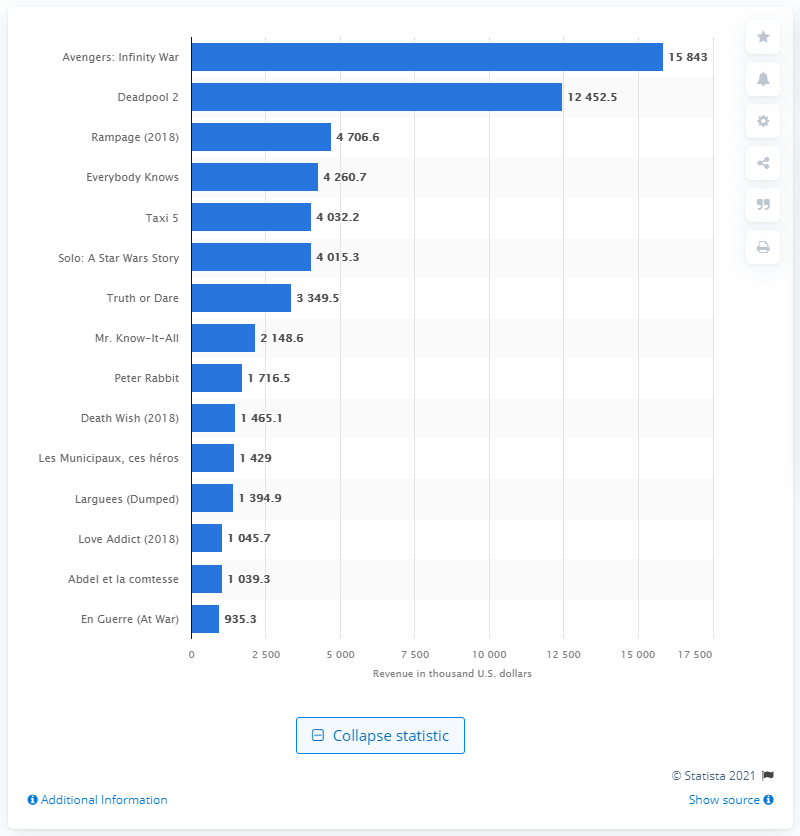Draw attention to some important aspects in this diagram. In May 2018, the highest grossing movie was "Avengers: Infinity War. 